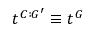Convert formula to latex. <formula><loc_0><loc_0><loc_500><loc_500>t ^ { C \colon G ^ { \prime } } \equiv t ^ { G }</formula> 